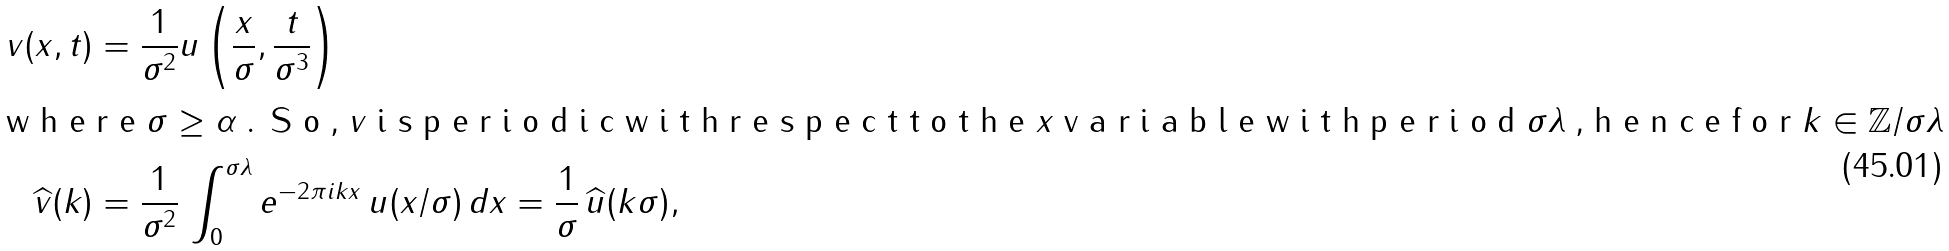Convert formula to latex. <formula><loc_0><loc_0><loc_500><loc_500>v ( x , t ) & = \frac { 1 } { \sigma ^ { 2 } } u \left ( \frac { x } { \sigma } , \frac { t } { \sigma ^ { 3 } } \right ) \\ \intertext { w h e r e $ \sigma \geq \alpha $ . S o , $ v $ i s p e r i o d i c w i t h r e s p e c t t o t h e $ x $ v a r i a b l e w i t h p e r i o d $ \sigma \lambda $ , h e n c e f o r $ k \in \mathbb { Z } / \sigma \lambda $ } \widehat { v } ( k ) & = \frac { 1 } { \sigma ^ { 2 } } \, \int _ { 0 } ^ { \sigma \lambda } e ^ { - 2 \pi i k x } \, u ( x / \sigma ) \, d x = \frac { 1 } { \sigma } \, \widehat { u } ( k \sigma ) ,</formula> 